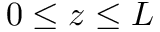Convert formula to latex. <formula><loc_0><loc_0><loc_500><loc_500>0 \leq z \leq L</formula> 